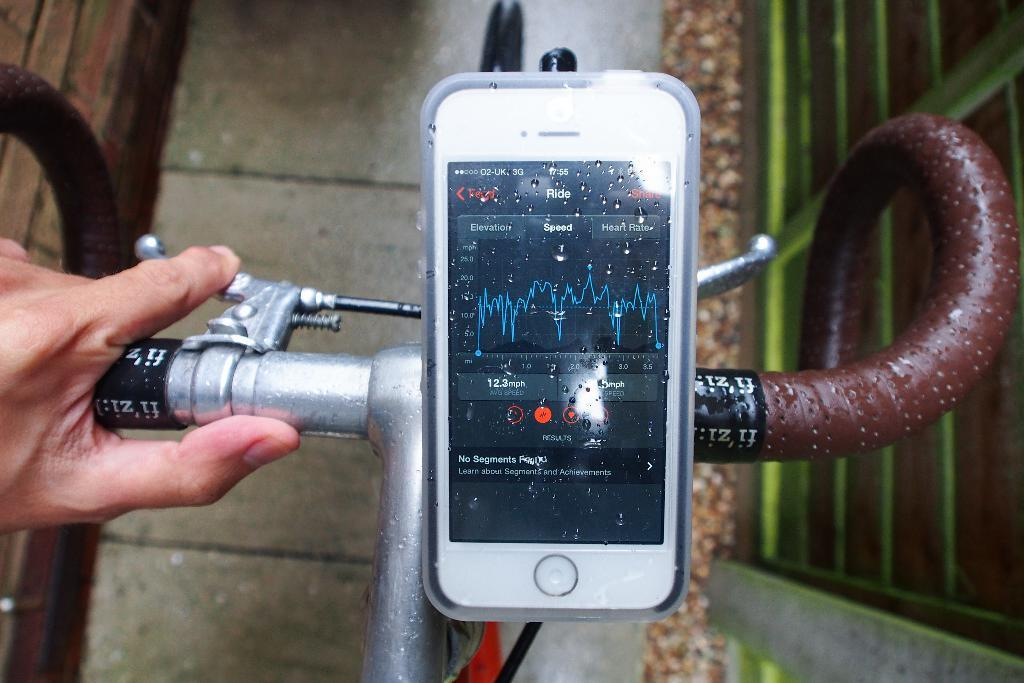<image>
Offer a succinct explanation of the picture presented. A phone showing an app that is able to measure speed. 